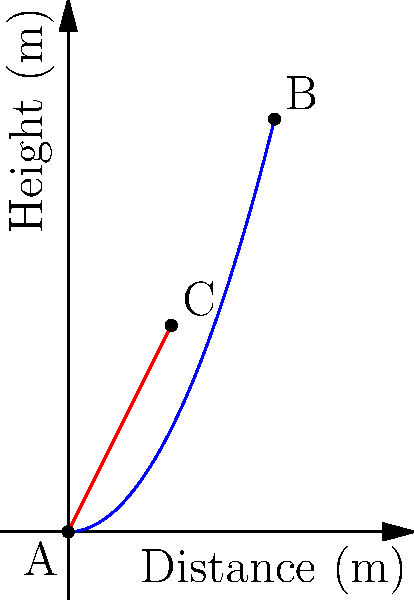In an urban drainage system, water flows from point A to point B through two different pipe configurations: a curved pipe (blue) and a straight pipe (red). Both pipes start at point A (0,0) and end at point B (4,8). The curved pipe follows the equation $y = 0.5x^2$, while the straight pipe passes through point C (2,4). Assuming steady, incompressible flow and neglecting friction, which pipe configuration will result in a higher water velocity at point B? To solve this problem, we'll use Bernoulli's equation and the concept of total head:

1) Bernoulli's equation: $\frac{p}{\rho g} + \frac{v^2}{2g} + z = constant$

2) Total head (H) = Pressure head + Velocity head + Elevation head

3) For both pipes, the pressure at A and B is atmospheric, so the pressure head term cancels out.

4) The elevation change is the same for both pipes (8m), so we can focus on the velocity head.

5) Conservation of energy states that the total head at A must equal the total head at B:

   $H_A = H_B$
   $z_A + \frac{v_A^2}{2g} = z_B + \frac{v_B^2}{2g}$

6) Rearranging to solve for $v_B$:

   $v_B = \sqrt{2g(z_A - z_B + \frac{v_A^2}{2g})}$

7) The initial velocity $v_A$ will be the same for both pipes. The difference lies in the path taken.

8) The straight pipe provides the shortest distance between A and B, meaning less energy is converted to potential energy during the flow.

9) In the curved pipe, water must rise higher at intermediate points, converting more kinetic energy to potential energy, which is then converted back to kinetic energy.

10) This conversion process is not 100% efficient due to viscous effects and turbulence, even if we're neglecting friction for simplicity.

Therefore, the straight pipe will result in a higher water velocity at point B.
Answer: Straight pipe 